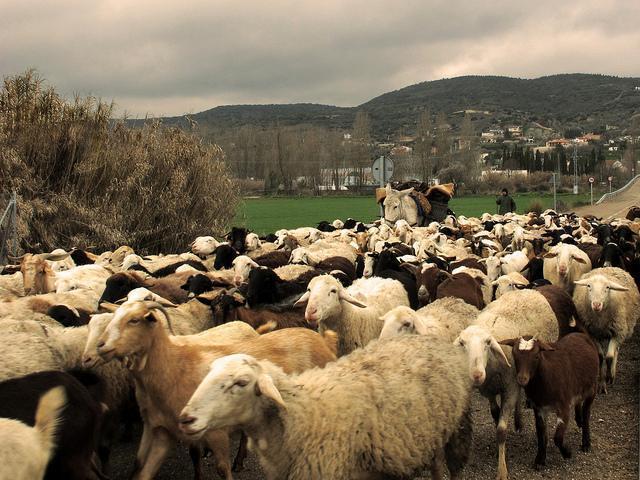How many sheep are there?
Give a very brief answer. 8. 